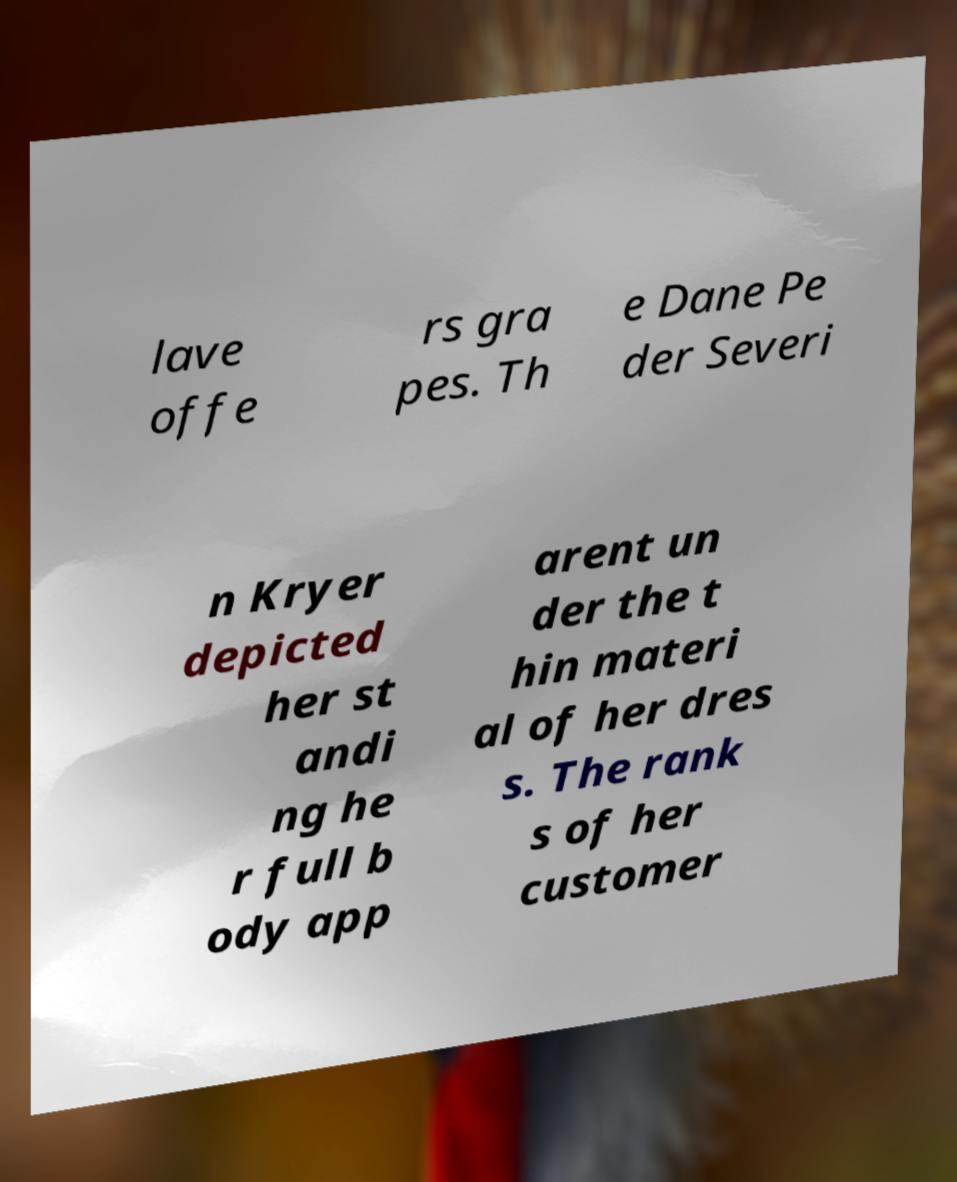For documentation purposes, I need the text within this image transcribed. Could you provide that? lave offe rs gra pes. Th e Dane Pe der Severi n Kryer depicted her st andi ng he r full b ody app arent un der the t hin materi al of her dres s. The rank s of her customer 